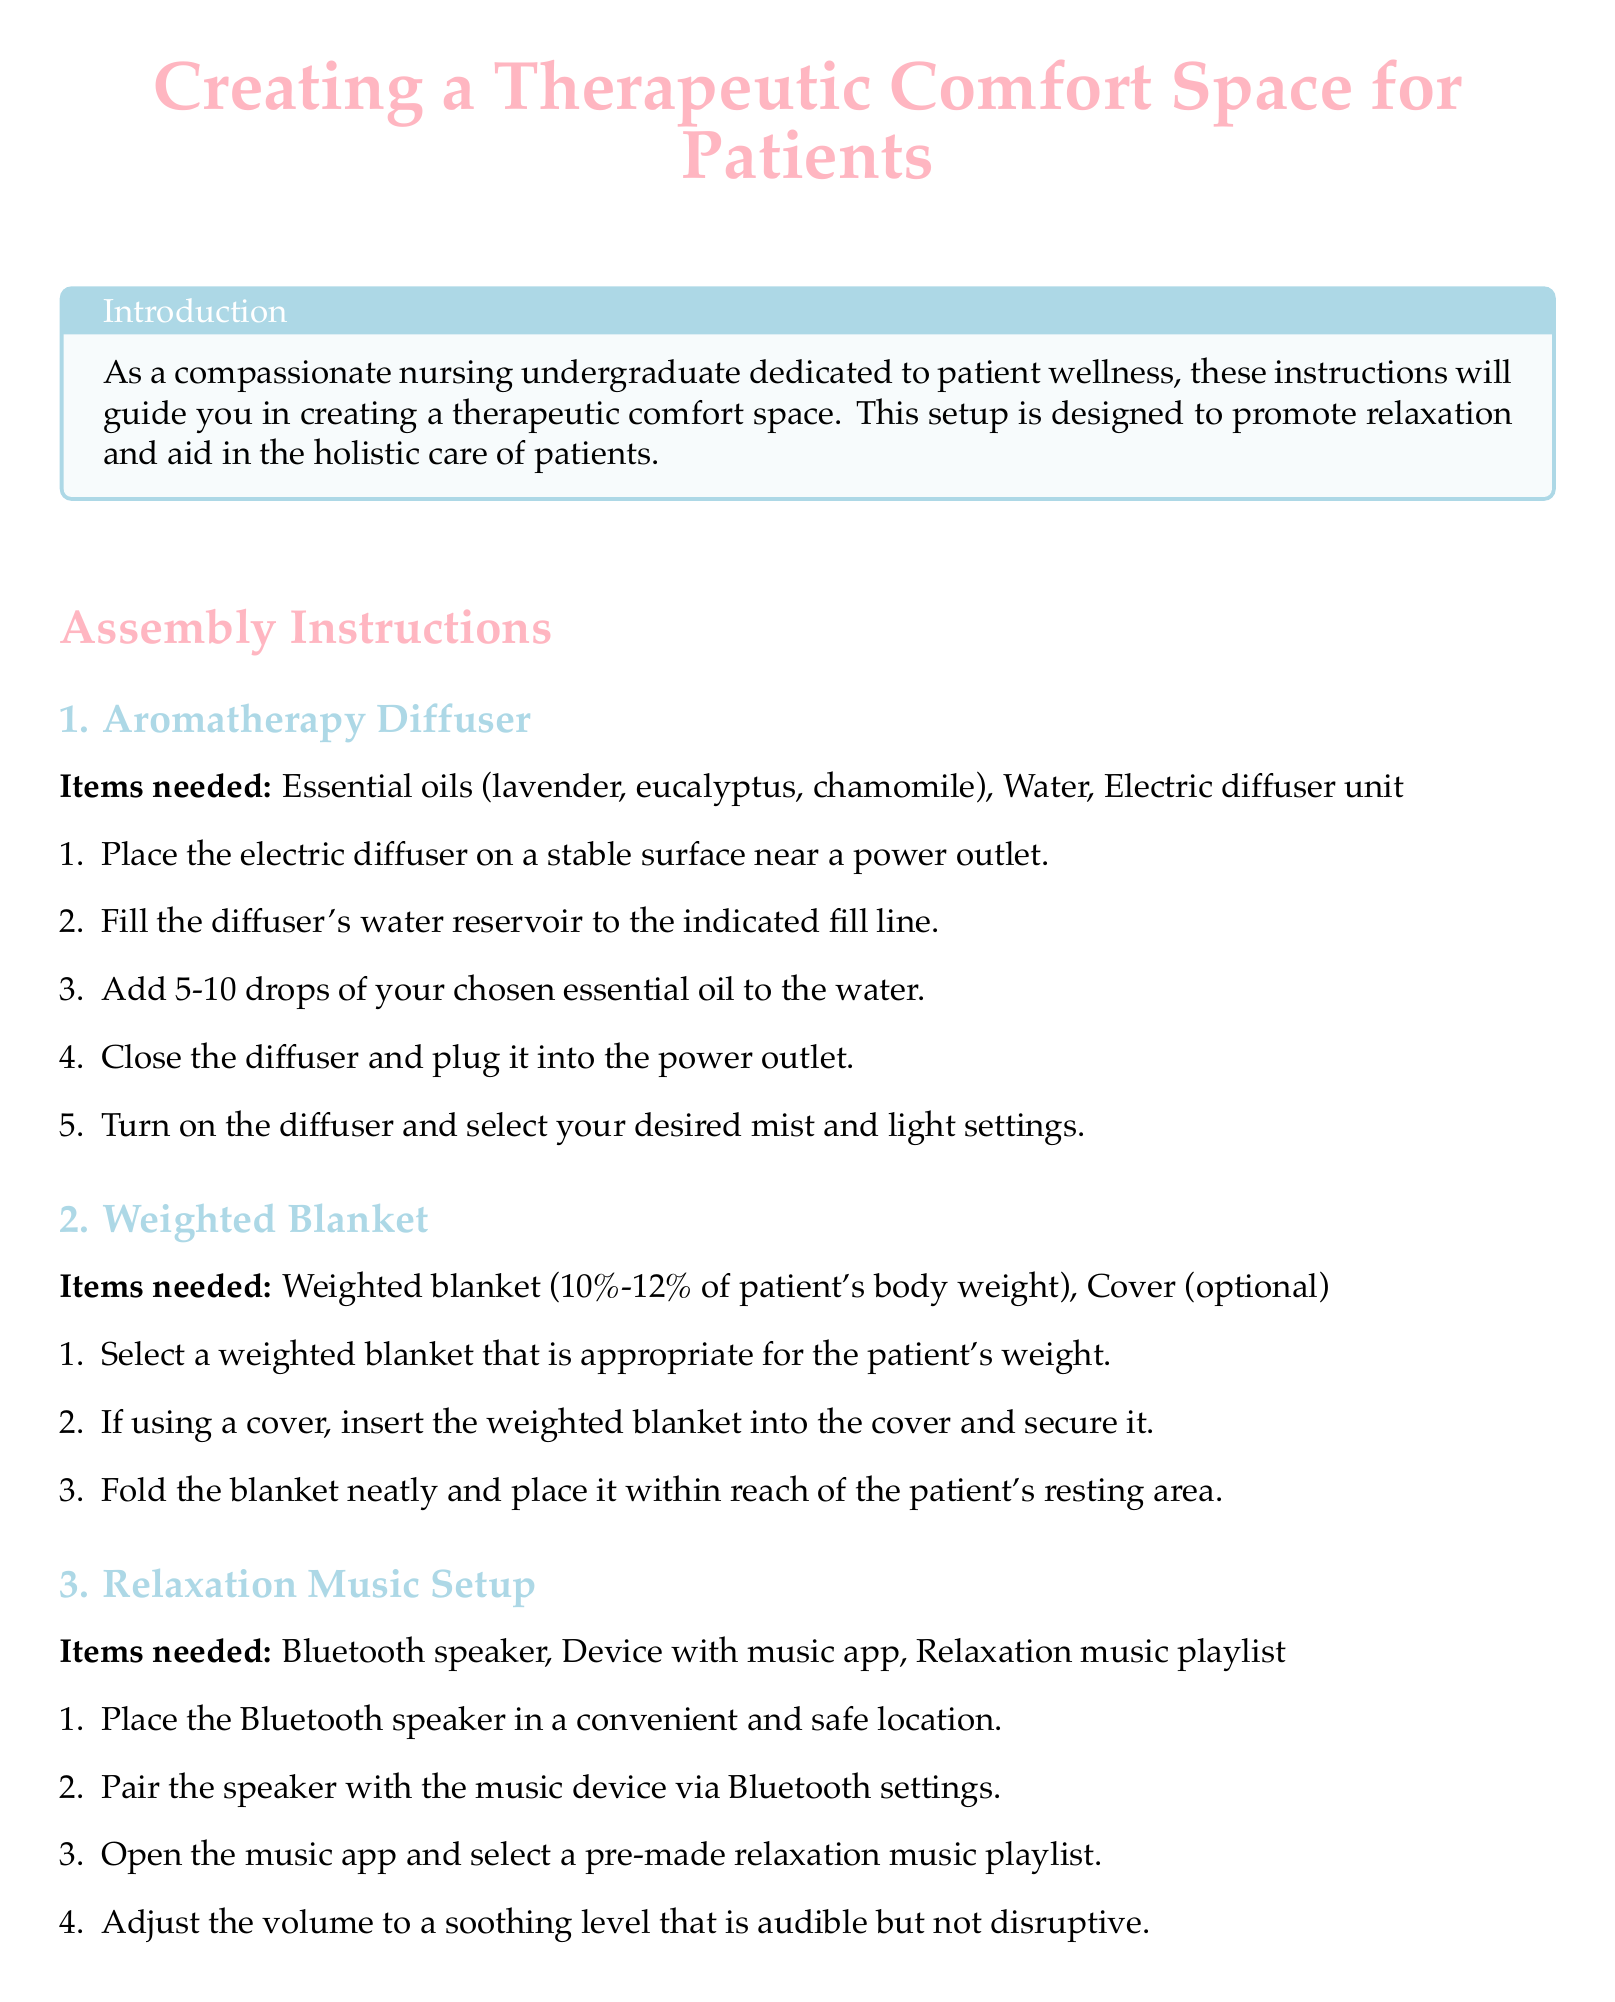What is the main objective of the assembly instructions? The document states that the assembly instructions aim to guide you in creating a therapeutic comfort space that promotes relaxation and aids in holistic care.
Answer: promoting relaxation How many drops of essential oil should be added to the diffuser? The instructions specify to add 5-10 drops of essential oil to the diffuser.
Answer: 5-10 drops What is the recommended weight range for the weighted blanket? The document advises that the weighted blanket should be 10%-12% of the patient's body weight.
Answer: 10%-12% What equipment is needed for setting up relaxation music? The assembly instructions list a Bluetooth speaker, device with music app, and relaxation music playlist as necessary items.
Answer: Bluetooth speaker, device with music app, relaxation music playlist What type of light source is suggested for soft lighting? The document suggests using LED candles or a Himalayan salt lamp for soft lighting in the patient's room.
Answer: LED candles or Himalayan salt lamp How should the weighted blanket be prepared for use? The instructions indicate that the weighted blanket should be selected based on the patient's weight and optionally placed in a cover before being folded and placed.
Answer: Insert into cover, fold What should be done with the power source for the lighting setup? It is instructed to ensure that the power source or batteries are properly connected and functional for the lighting setup.
Answer: properly connected and functional What color is used for the title in the document? The title is colored pink, as specified in the document.
Answer: pink 